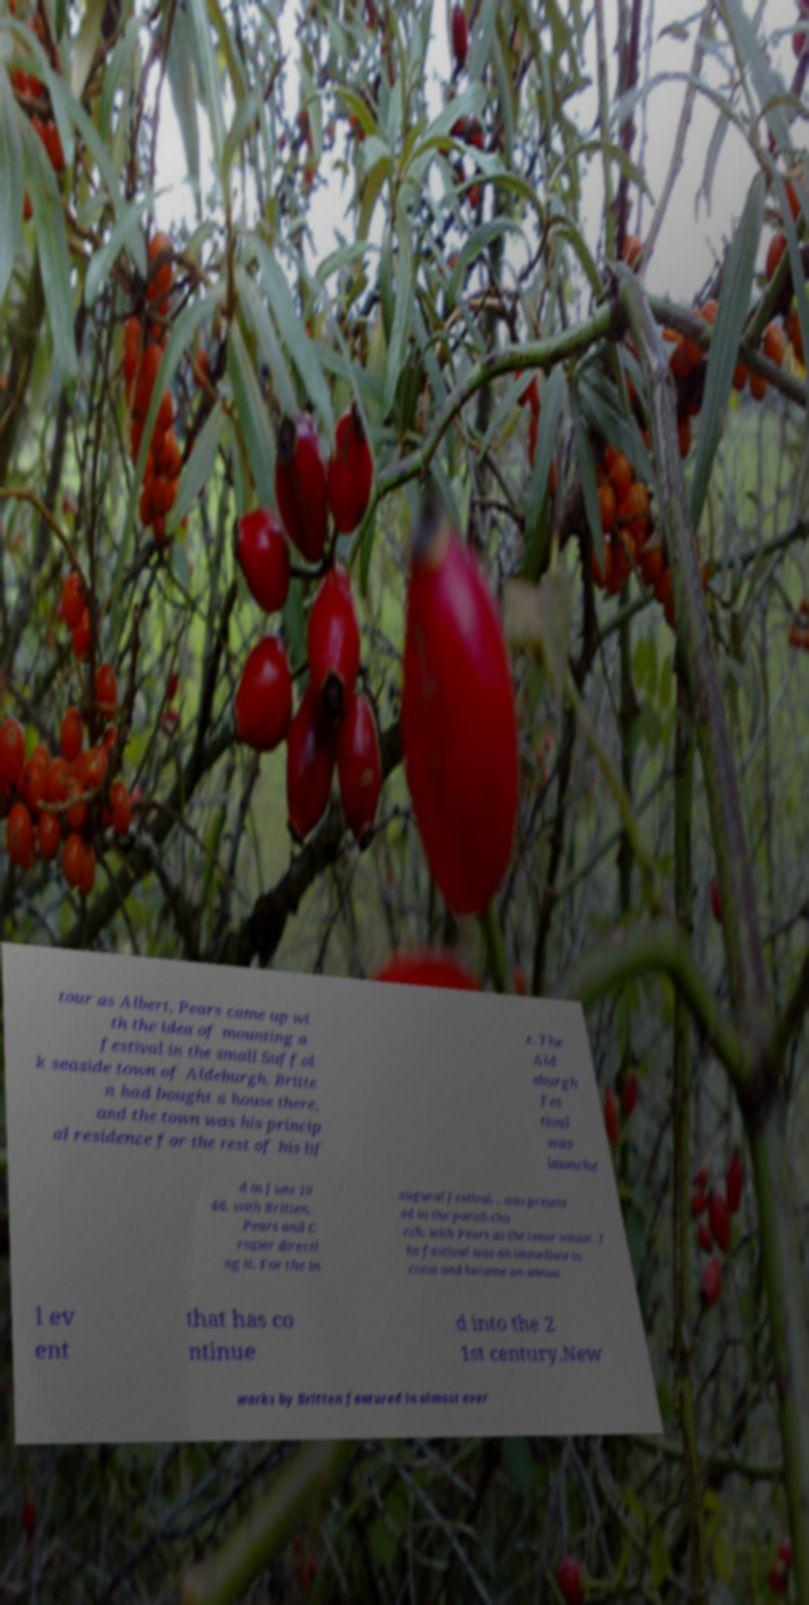Please identify and transcribe the text found in this image. tour as Albert, Pears came up wi th the idea of mounting a festival in the small Suffol k seaside town of Aldeburgh. Britte n had bought a house there, and the town was his princip al residence for the rest of his lif e. The Ald eburgh Fes tival was launche d in June 19 48, with Britten, Pears and C rozier directi ng it. For the in augural festival, , was present ed in the parish chu rch, with Pears as the tenor soloist. T he festival was an immediate su ccess and became an annua l ev ent that has co ntinue d into the 2 1st century.New works by Britten featured in almost ever 